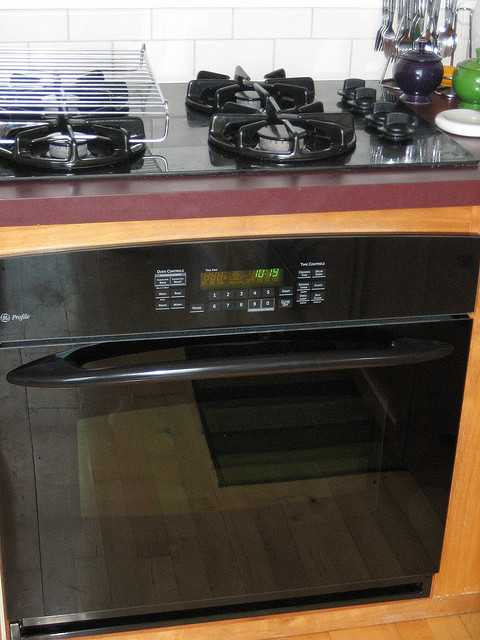<image>What is the brand of oven in the picture? I don't know what the brand of the oven in the picture is. It could be Whirlpool, Ge, Frigid air or Kenmore. What is the brand of oven in the picture? I don't know the brand of the oven in the picture. It can be Whirlpool, GE, Frigidaire, or Kenmore. 